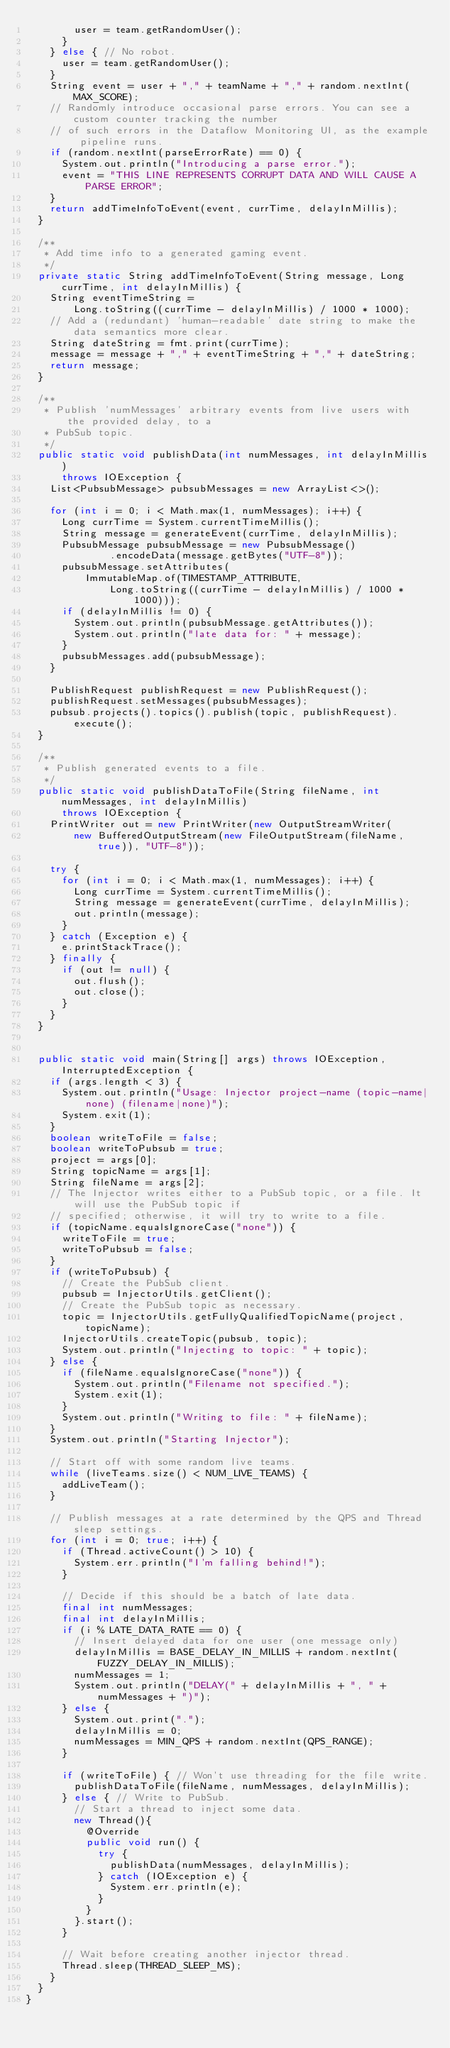<code> <loc_0><loc_0><loc_500><loc_500><_Java_>        user = team.getRandomUser();
      }
    } else { // No robot.
      user = team.getRandomUser();
    }
    String event = user + "," + teamName + "," + random.nextInt(MAX_SCORE);
    // Randomly introduce occasional parse errors. You can see a custom counter tracking the number
    // of such errors in the Dataflow Monitoring UI, as the example pipeline runs.
    if (random.nextInt(parseErrorRate) == 0) {
      System.out.println("Introducing a parse error.");
      event = "THIS LINE REPRESENTS CORRUPT DATA AND WILL CAUSE A PARSE ERROR";
    }
    return addTimeInfoToEvent(event, currTime, delayInMillis);
  }

  /**
   * Add time info to a generated gaming event.
   */
  private static String addTimeInfoToEvent(String message, Long currTime, int delayInMillis) {
    String eventTimeString =
        Long.toString((currTime - delayInMillis) / 1000 * 1000);
    // Add a (redundant) 'human-readable' date string to make the data semantics more clear.
    String dateString = fmt.print(currTime);
    message = message + "," + eventTimeString + "," + dateString;
    return message;
  }

  /**
   * Publish 'numMessages' arbitrary events from live users with the provided delay, to a
   * PubSub topic.
   */
  public static void publishData(int numMessages, int delayInMillis)
      throws IOException {
    List<PubsubMessage> pubsubMessages = new ArrayList<>();

    for (int i = 0; i < Math.max(1, numMessages); i++) {
      Long currTime = System.currentTimeMillis();
      String message = generateEvent(currTime, delayInMillis);
      PubsubMessage pubsubMessage = new PubsubMessage()
              .encodeData(message.getBytes("UTF-8"));
      pubsubMessage.setAttributes(
          ImmutableMap.of(TIMESTAMP_ATTRIBUTE,
              Long.toString((currTime - delayInMillis) / 1000 * 1000)));
      if (delayInMillis != 0) {
        System.out.println(pubsubMessage.getAttributes());
        System.out.println("late data for: " + message);
      }
      pubsubMessages.add(pubsubMessage);
    }

    PublishRequest publishRequest = new PublishRequest();
    publishRequest.setMessages(pubsubMessages);
    pubsub.projects().topics().publish(topic, publishRequest).execute();
  }

  /**
   * Publish generated events to a file.
   */
  public static void publishDataToFile(String fileName, int numMessages, int delayInMillis)
      throws IOException {
    PrintWriter out = new PrintWriter(new OutputStreamWriter(
        new BufferedOutputStream(new FileOutputStream(fileName, true)), "UTF-8"));

    try {
      for (int i = 0; i < Math.max(1, numMessages); i++) {
        Long currTime = System.currentTimeMillis();
        String message = generateEvent(currTime, delayInMillis);
        out.println(message);
      }
    } catch (Exception e) {
      e.printStackTrace();
    } finally {
      if (out != null) {
        out.flush();
        out.close();
      }
    }
  }


  public static void main(String[] args) throws IOException, InterruptedException {
    if (args.length < 3) {
      System.out.println("Usage: Injector project-name (topic-name|none) (filename|none)");
      System.exit(1);
    }
    boolean writeToFile = false;
    boolean writeToPubsub = true;
    project = args[0];
    String topicName = args[1];
    String fileName = args[2];
    // The Injector writes either to a PubSub topic, or a file. It will use the PubSub topic if
    // specified; otherwise, it will try to write to a file.
    if (topicName.equalsIgnoreCase("none")) {
      writeToFile = true;
      writeToPubsub = false;
    }
    if (writeToPubsub) {
      // Create the PubSub client.
      pubsub = InjectorUtils.getClient();
      // Create the PubSub topic as necessary.
      topic = InjectorUtils.getFullyQualifiedTopicName(project, topicName);
      InjectorUtils.createTopic(pubsub, topic);
      System.out.println("Injecting to topic: " + topic);
    } else {
      if (fileName.equalsIgnoreCase("none")) {
        System.out.println("Filename not specified.");
        System.exit(1);
      }
      System.out.println("Writing to file: " + fileName);
    }
    System.out.println("Starting Injector");

    // Start off with some random live teams.
    while (liveTeams.size() < NUM_LIVE_TEAMS) {
      addLiveTeam();
    }

    // Publish messages at a rate determined by the QPS and Thread sleep settings.
    for (int i = 0; true; i++) {
      if (Thread.activeCount() > 10) {
        System.err.println("I'm falling behind!");
      }

      // Decide if this should be a batch of late data.
      final int numMessages;
      final int delayInMillis;
      if (i % LATE_DATA_RATE == 0) {
        // Insert delayed data for one user (one message only)
        delayInMillis = BASE_DELAY_IN_MILLIS + random.nextInt(FUZZY_DELAY_IN_MILLIS);
        numMessages = 1;
        System.out.println("DELAY(" + delayInMillis + ", " + numMessages + ")");
      } else {
        System.out.print(".");
        delayInMillis = 0;
        numMessages = MIN_QPS + random.nextInt(QPS_RANGE);
      }

      if (writeToFile) { // Won't use threading for the file write.
        publishDataToFile(fileName, numMessages, delayInMillis);
      } else { // Write to PubSub.
        // Start a thread to inject some data.
        new Thread(){
          @Override
          public void run() {
            try {
              publishData(numMessages, delayInMillis);
            } catch (IOException e) {
              System.err.println(e);
            }
          }
        }.start();
      }

      // Wait before creating another injector thread.
      Thread.sleep(THREAD_SLEEP_MS);
    }
  }
}
</code> 